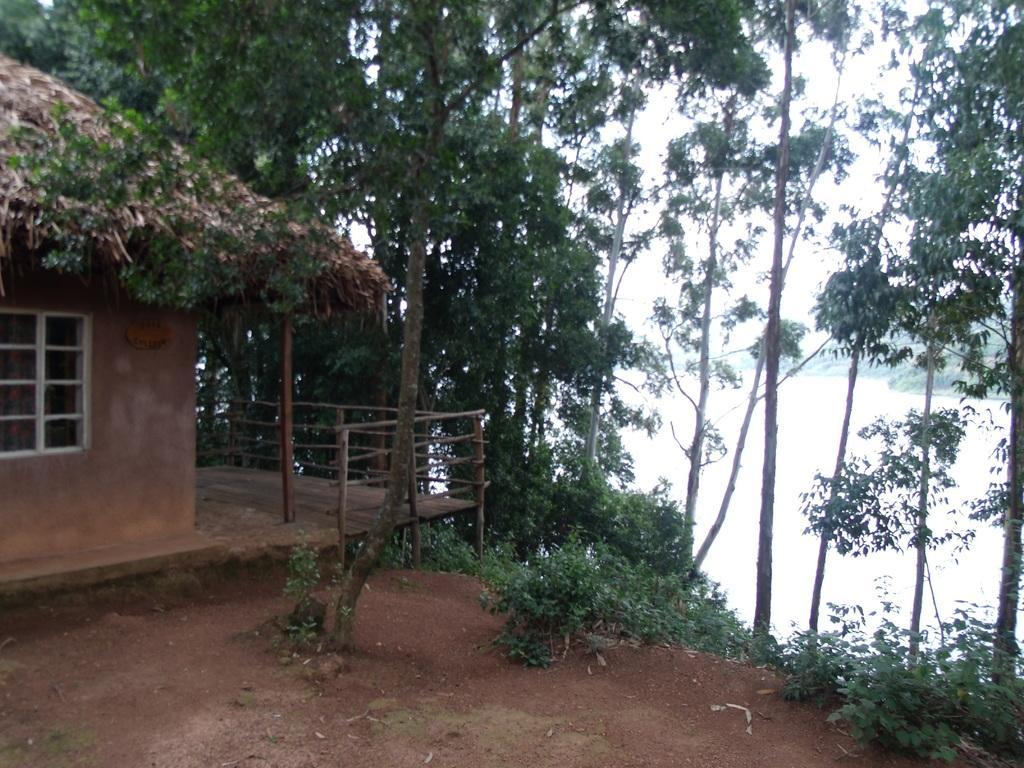How would you summarize this image in a sentence or two? In this image I can see the ground, the house which is brown and white in color, the wooden railing and few trees. In the background I can see the water and the sky. 